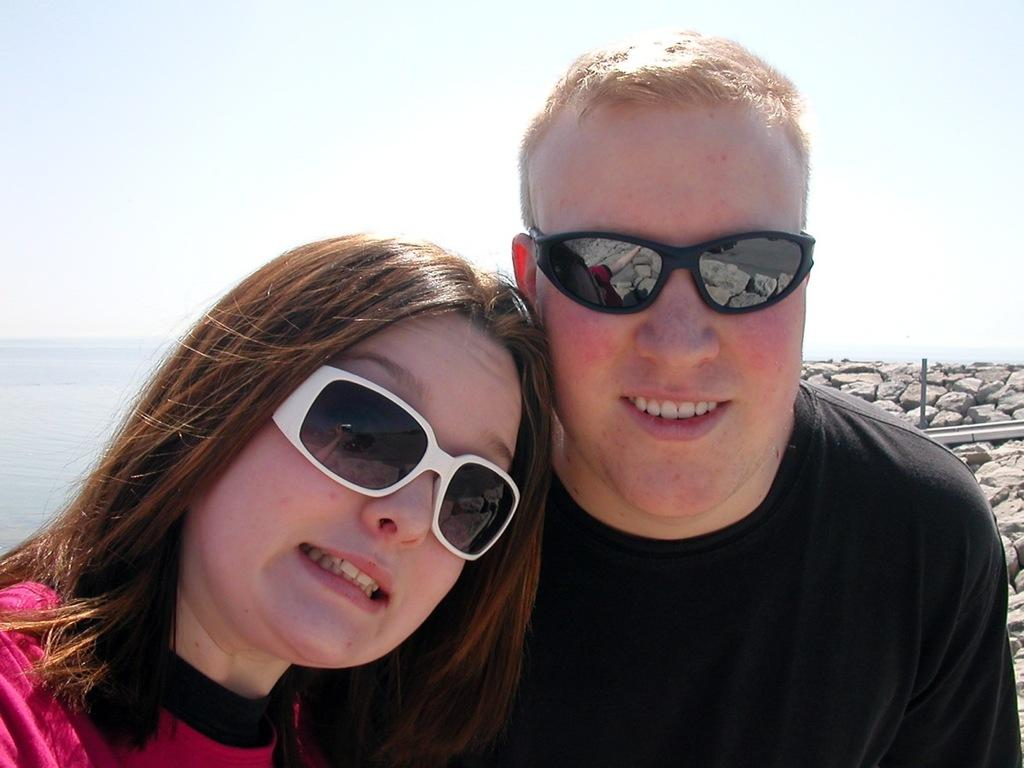What is the gender of the person in the image wearing glasses? There are two people wearing glasses in the image, a man and a woman. What is a common feature between the man and the woman in the image? Both the man and the woman are wearing glasses. What can be seen in the background of the image? There are stones, sea, and sky visible in the background of the image. What type of straw is the man holding in the image? There is no straw present in the image. How many dogs are visible in the image? There are no dogs present in the image. 